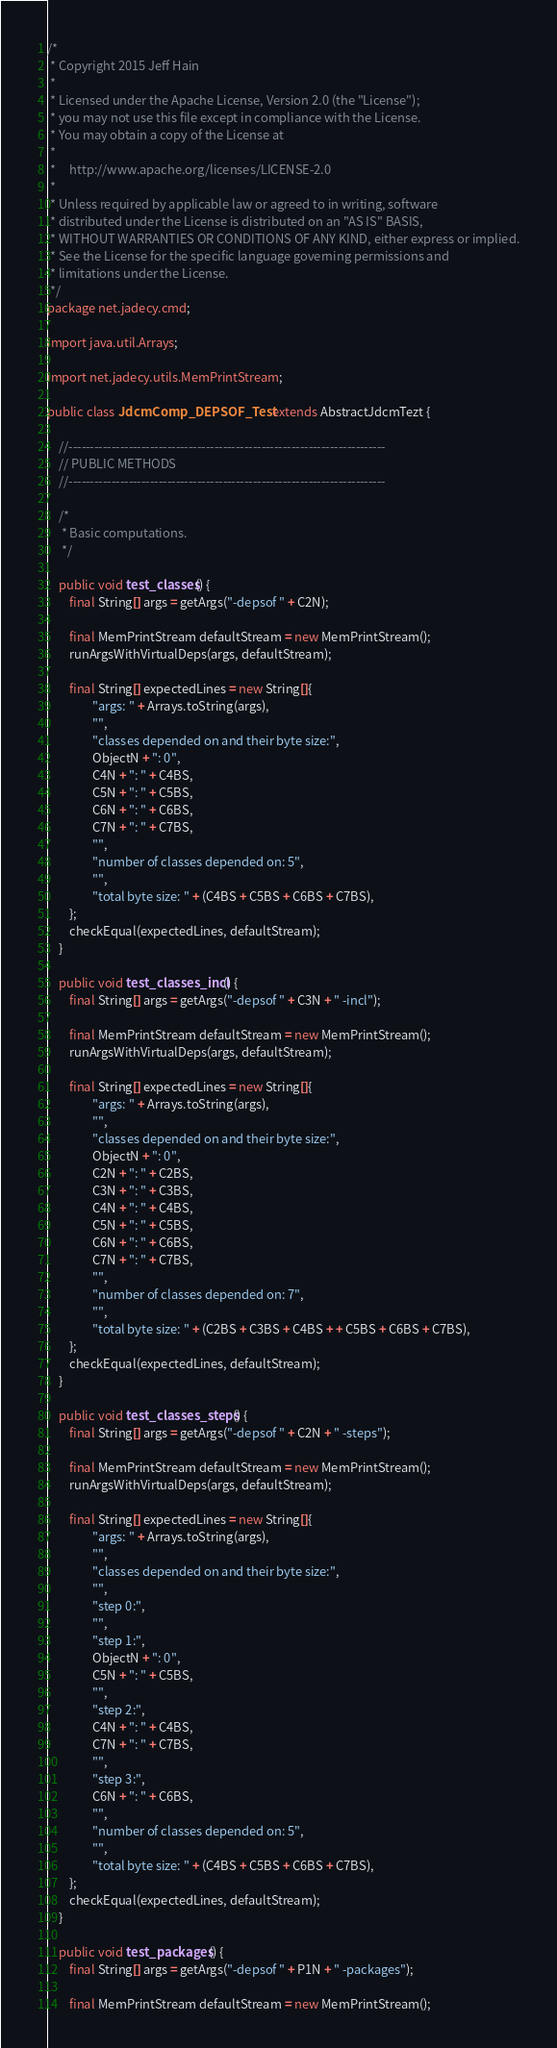<code> <loc_0><loc_0><loc_500><loc_500><_Java_>/*
 * Copyright 2015 Jeff Hain
 *
 * Licensed under the Apache License, Version 2.0 (the "License");
 * you may not use this file except in compliance with the License.
 * You may obtain a copy of the License at
 *
 *     http://www.apache.org/licenses/LICENSE-2.0
 *
 * Unless required by applicable law or agreed to in writing, software
 * distributed under the License is distributed on an "AS IS" BASIS,
 * WITHOUT WARRANTIES OR CONDITIONS OF ANY KIND, either express or implied.
 * See the License for the specific language governing permissions and
 * limitations under the License.
 */
package net.jadecy.cmd;

import java.util.Arrays;

import net.jadecy.utils.MemPrintStream;

public class JdcmComp_DEPSOF_Test extends AbstractJdcmTezt {

    //--------------------------------------------------------------------------
    // PUBLIC METHODS
    //--------------------------------------------------------------------------

    /*
     * Basic computations.
     */

    public void test_classes() {
        final String[] args = getArgs("-depsof " + C2N);

        final MemPrintStream defaultStream = new MemPrintStream();
        runArgsWithVirtualDeps(args, defaultStream);

        final String[] expectedLines = new String[]{
                "args: " + Arrays.toString(args),
                "",
                "classes depended on and their byte size:",
                ObjectN + ": 0",
                C4N + ": " + C4BS,
                C5N + ": " + C5BS,
                C6N + ": " + C6BS,
                C7N + ": " + C7BS,
                "",
                "number of classes depended on: 5",
                "",
                "total byte size: " + (C4BS + C5BS + C6BS + C7BS),
        };
        checkEqual(expectedLines, defaultStream);
    }

    public void test_classes_incl() {
        final String[] args = getArgs("-depsof " + C3N + " -incl");

        final MemPrintStream defaultStream = new MemPrintStream();
        runArgsWithVirtualDeps(args, defaultStream);

        final String[] expectedLines = new String[]{
                "args: " + Arrays.toString(args),
                "",
                "classes depended on and their byte size:",
                ObjectN + ": 0",
                C2N + ": " + C2BS,
                C3N + ": " + C3BS,
                C4N + ": " + C4BS,
                C5N + ": " + C5BS,
                C6N + ": " + C6BS,
                C7N + ": " + C7BS,
                "",
                "number of classes depended on: 7",
                "",
                "total byte size: " + (C2BS + C3BS + C4BS + + C5BS + C6BS + C7BS),
        };
        checkEqual(expectedLines, defaultStream);
    }

    public void test_classes_steps() {
        final String[] args = getArgs("-depsof " + C2N + " -steps");

        final MemPrintStream defaultStream = new MemPrintStream();
        runArgsWithVirtualDeps(args, defaultStream);

        final String[] expectedLines = new String[]{
                "args: " + Arrays.toString(args),
                "",
                "classes depended on and their byte size:",
                "",
                "step 0:",
                "",
                "step 1:",
                ObjectN + ": 0",
                C5N + ": " + C5BS,
                "",
                "step 2:",
                C4N + ": " + C4BS,
                C7N + ": " + C7BS,
                "",
                "step 3:",
                C6N + ": " + C6BS,
                "",
                "number of classes depended on: 5",
                "",
                "total byte size: " + (C4BS + C5BS + C6BS + C7BS),
        };
        checkEqual(expectedLines, defaultStream);
    }

    public void test_packages() {
        final String[] args = getArgs("-depsof " + P1N + " -packages");

        final MemPrintStream defaultStream = new MemPrintStream();</code> 